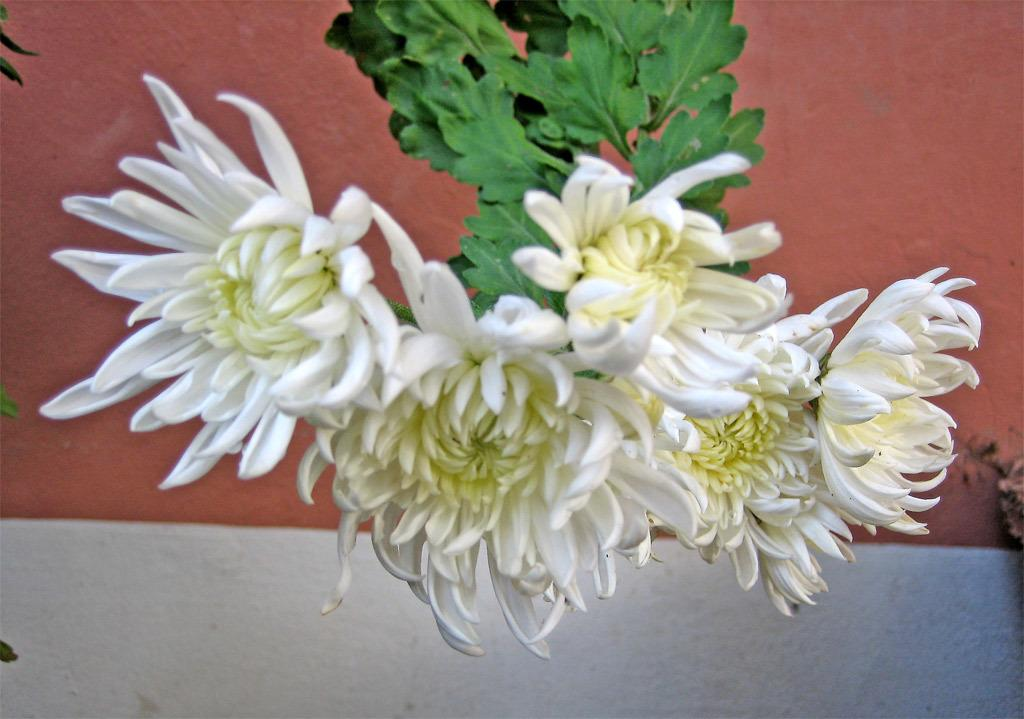What type of flowers are in the image? The image contains white color flowers. What color are the leaves of the flowers? The flowers have green leaves. What can be seen in the background of the image? There is a wall in the background of the image. What colors are present on the wall? The wall has red and white colors. What nation is represented by the flowers in the image? The image does not represent any specific nation; it simply contains white color flowers with green leaves. 